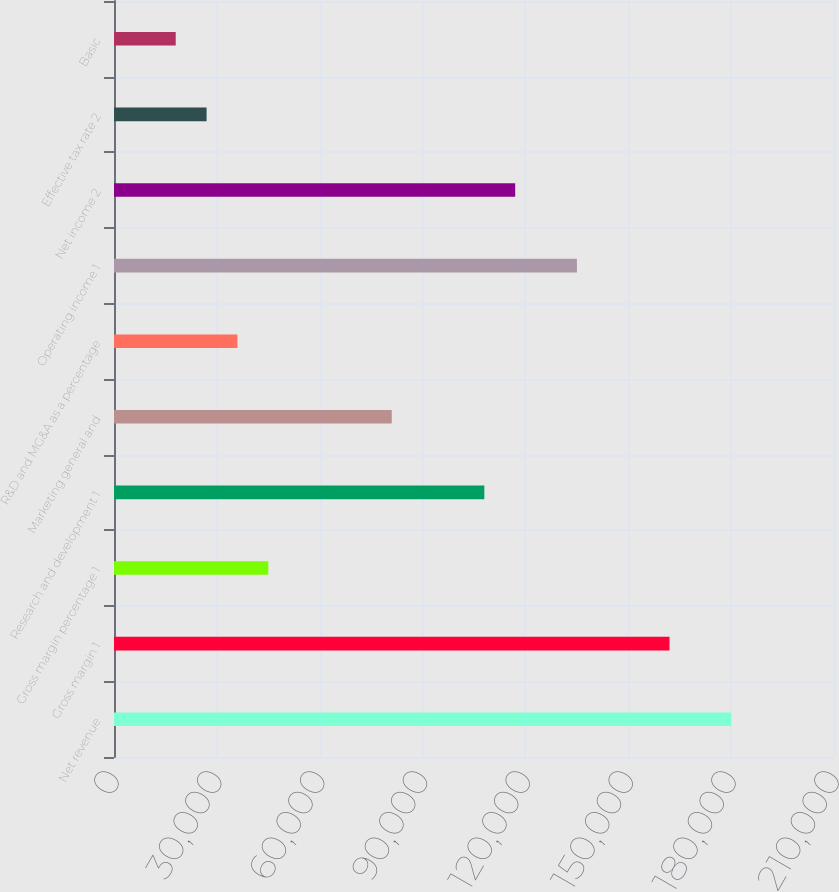Convert chart. <chart><loc_0><loc_0><loc_500><loc_500><bar_chart><fcel>Net revenue<fcel>Gross margin 1<fcel>Gross margin percentage 1<fcel>Research and development 1<fcel>Marketing general and<fcel>R&D and MG&A as a percentage<fcel>Operating income 1<fcel>Net income 2<fcel>Effective tax rate 2<fcel>Basic<nl><fcel>180023<fcel>162021<fcel>45006.4<fcel>108014<fcel>81010.9<fcel>36005.3<fcel>135018<fcel>117015<fcel>27004.2<fcel>18003.1<nl></chart> 